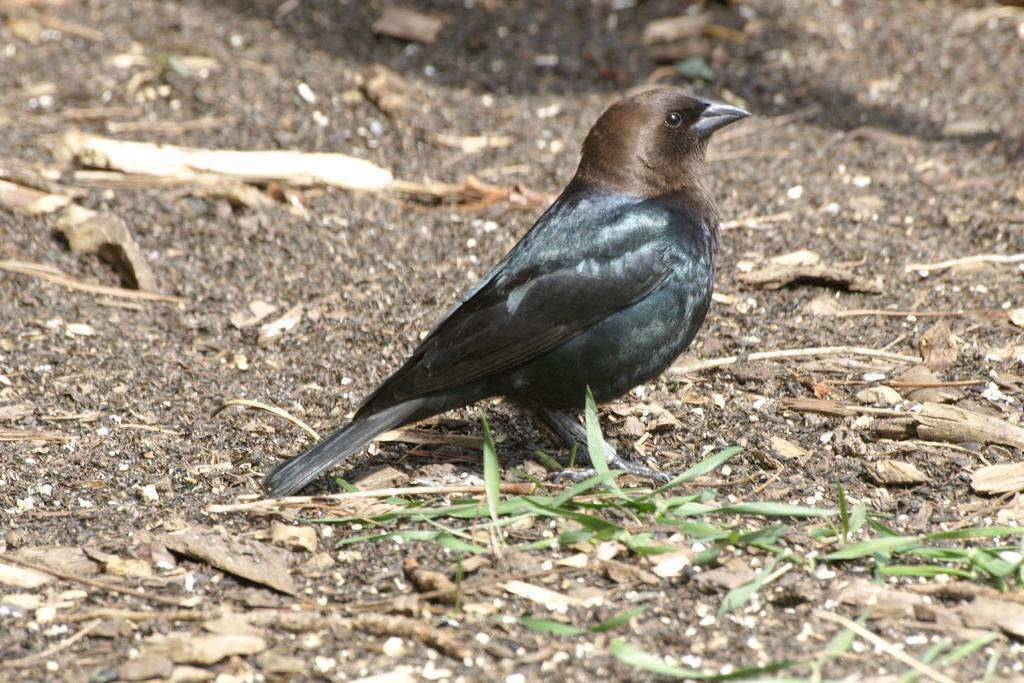Could you give a brief overview of what you see in this image? In the foreground of this image, there is a bird on the ground where we can see few wooden sticks and the leaves. 